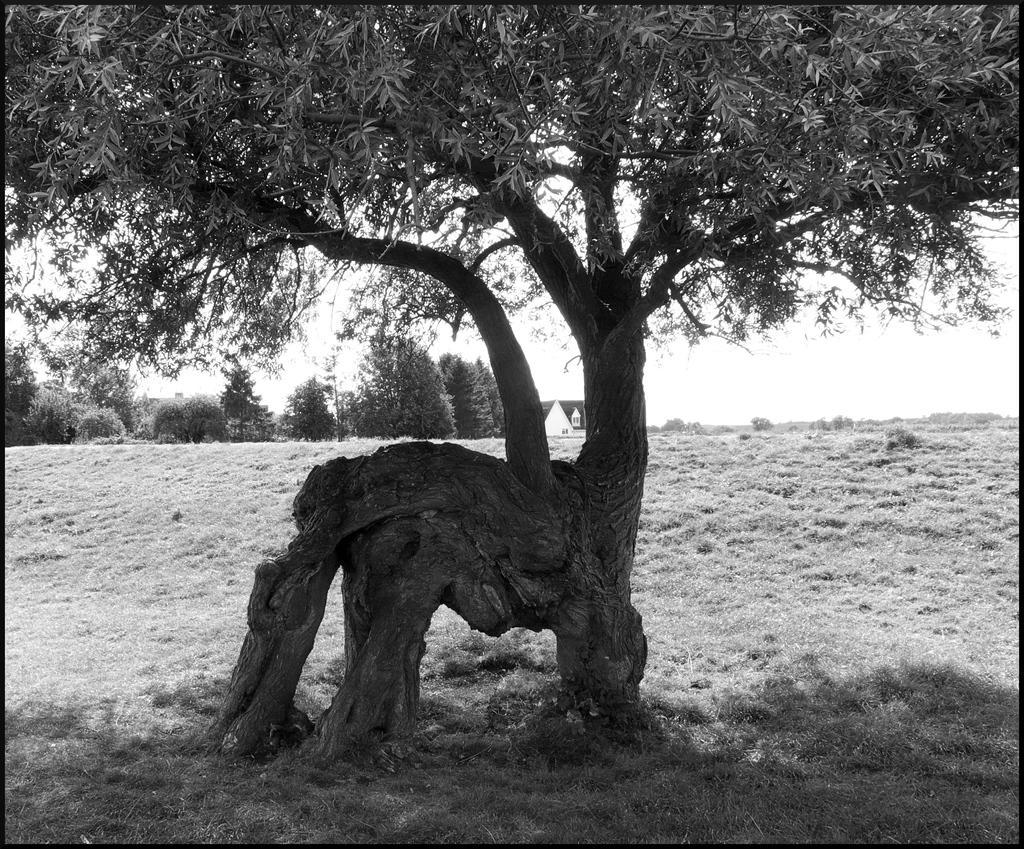Can you describe this image briefly? In this picture I can see there is a tree and there are leafs and in the backdrop there are many other trees and the sky is clear. 